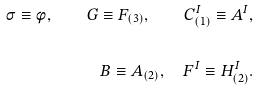<formula> <loc_0><loc_0><loc_500><loc_500>\sigma \equiv \phi , \quad G \equiv F _ { ( 3 ) } , \quad C _ { ( 1 ) } ^ { I } \equiv A ^ { I } , \\ \\ B \equiv A _ { ( 2 ) } , \quad F ^ { I } \equiv H _ { ( 2 ) } ^ { I } .</formula> 